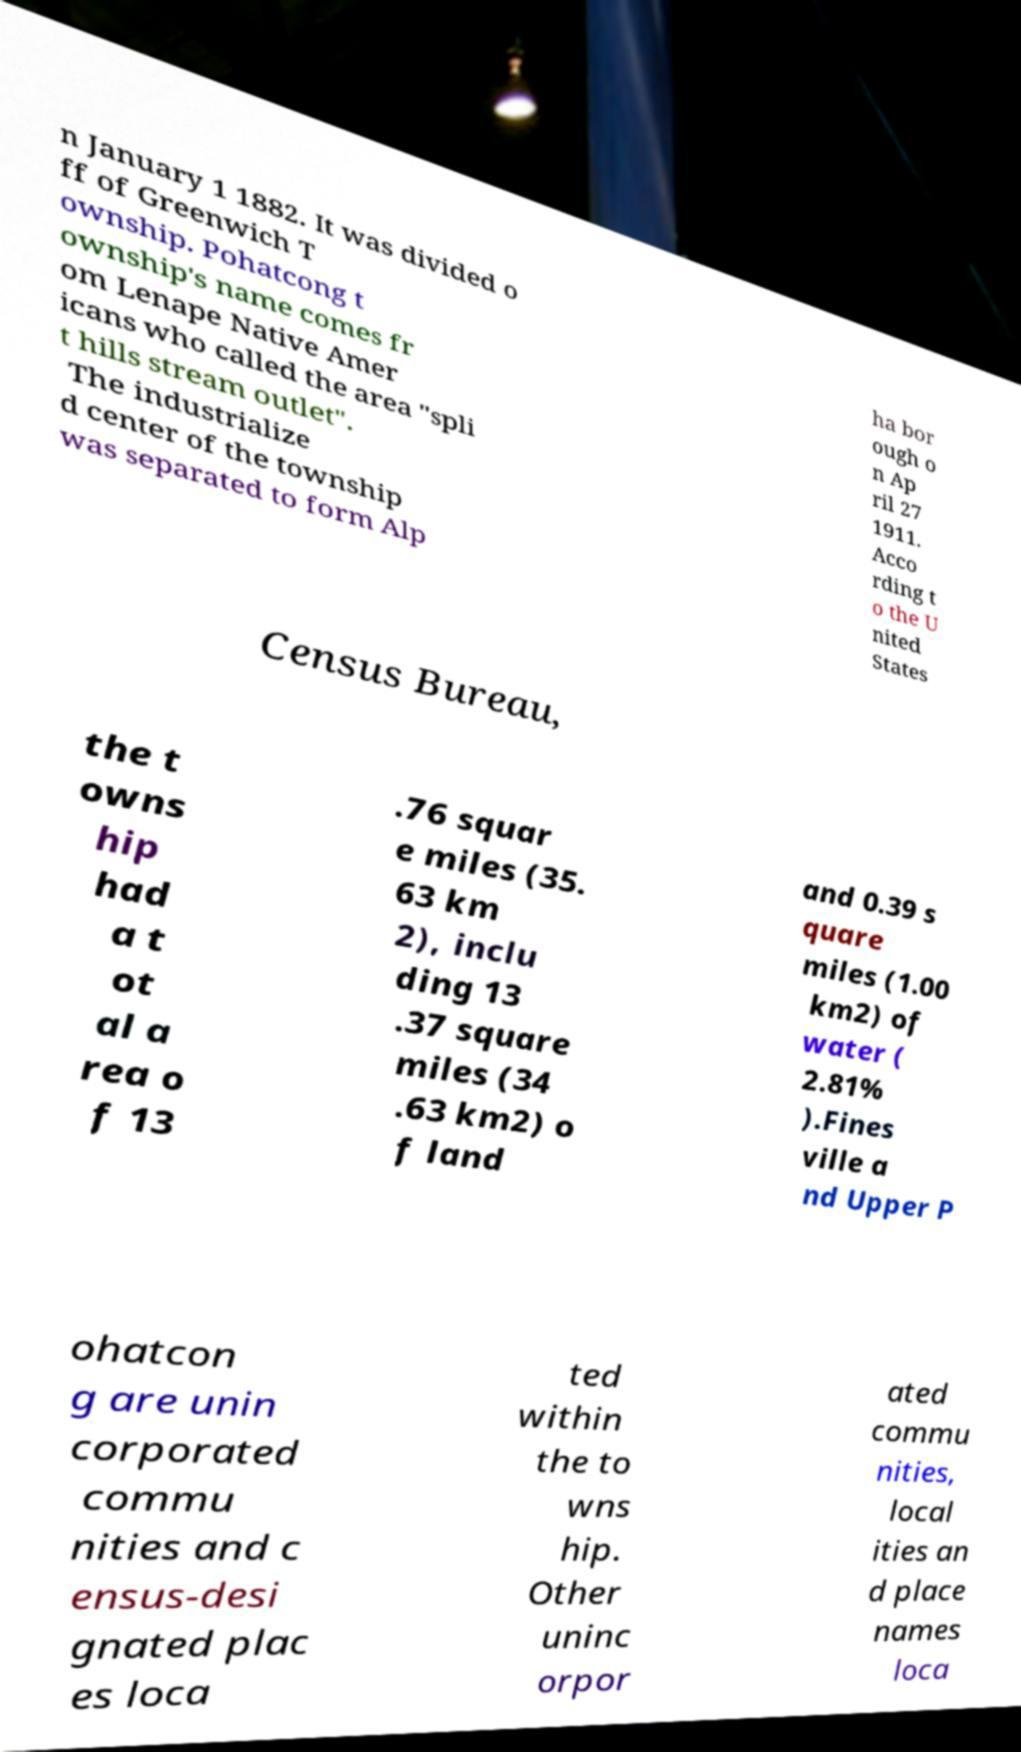There's text embedded in this image that I need extracted. Can you transcribe it verbatim? n January 1 1882. It was divided o ff of Greenwich T ownship. Pohatcong t ownship's name comes fr om Lenape Native Amer icans who called the area "spli t hills stream outlet". The industrialize d center of the township was separated to form Alp ha bor ough o n Ap ril 27 1911. Acco rding t o the U nited States Census Bureau, the t owns hip had a t ot al a rea o f 13 .76 squar e miles (35. 63 km 2), inclu ding 13 .37 square miles (34 .63 km2) o f land and 0.39 s quare miles (1.00 km2) of water ( 2.81% ).Fines ville a nd Upper P ohatcon g are unin corporated commu nities and c ensus-desi gnated plac es loca ted within the to wns hip. Other uninc orpor ated commu nities, local ities an d place names loca 